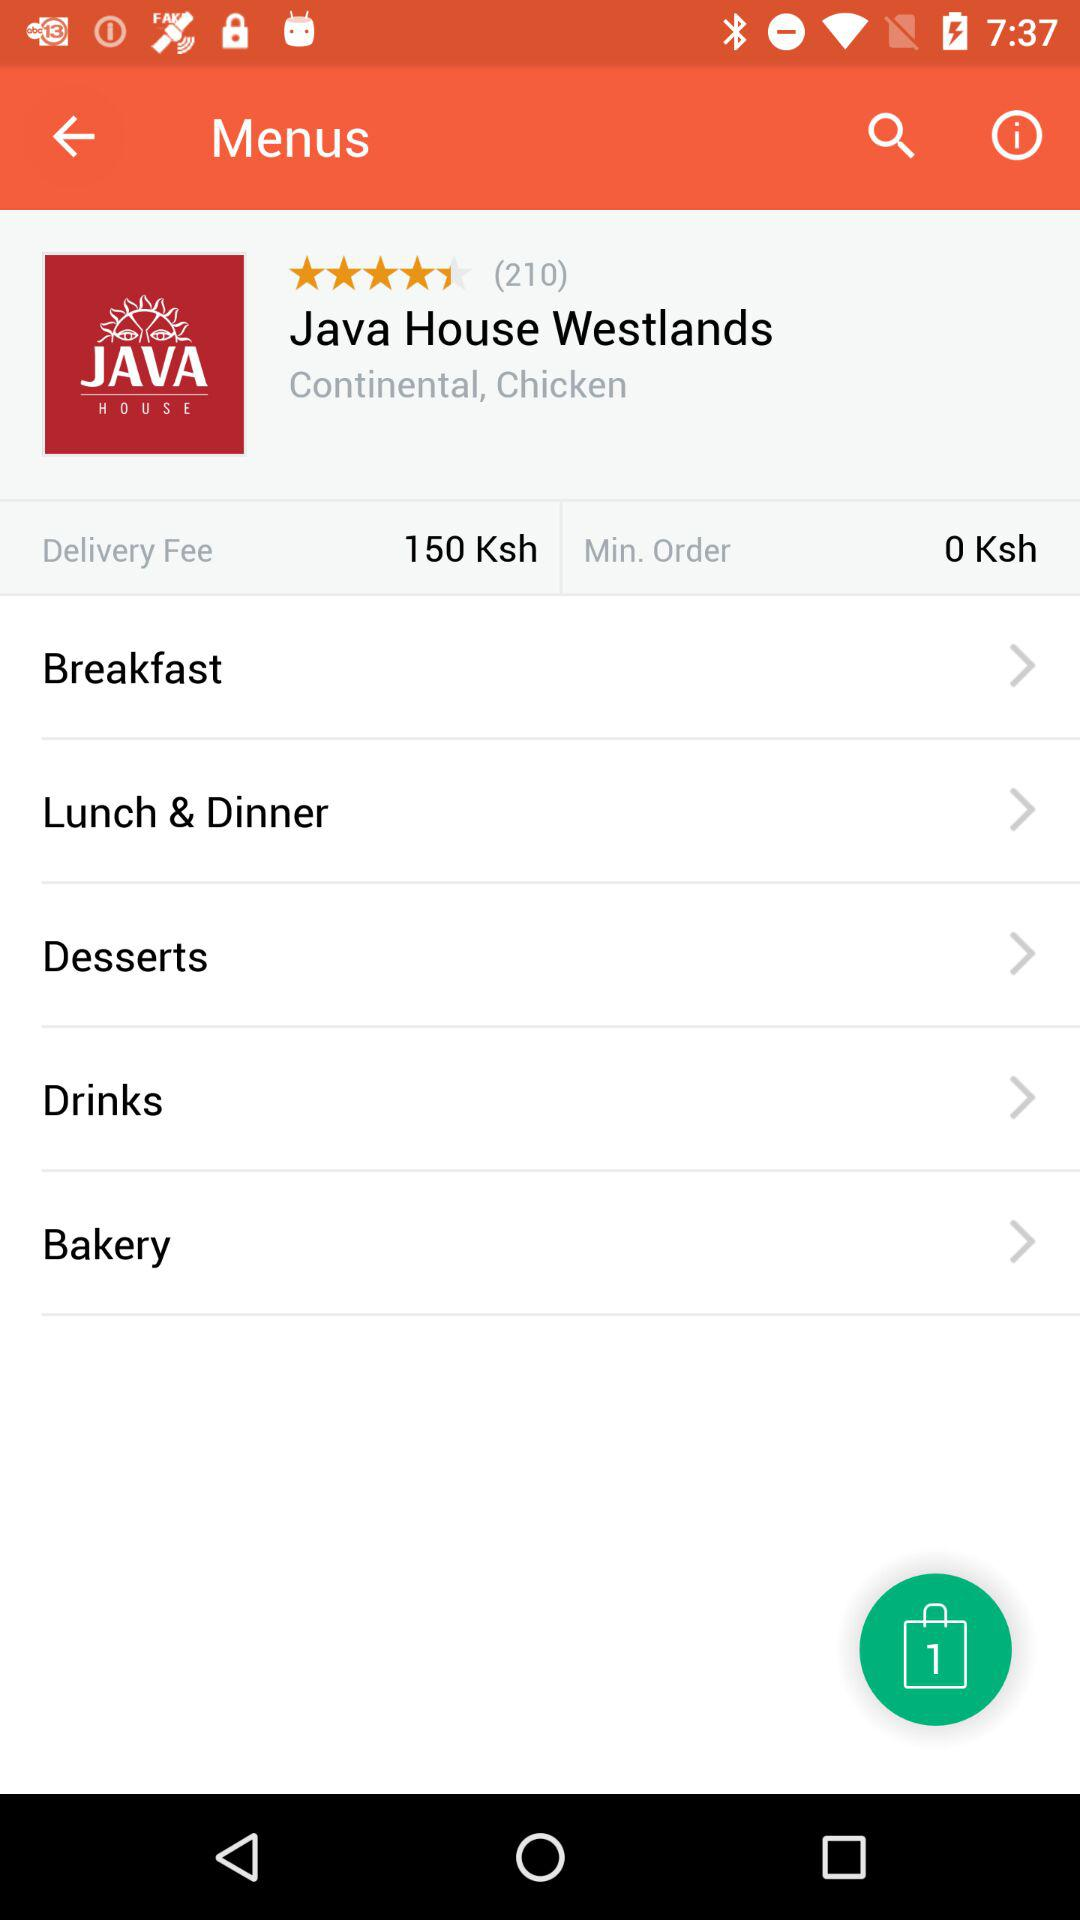What is the name of the restaurant? The name of the restaurant is Java House Westlands. 